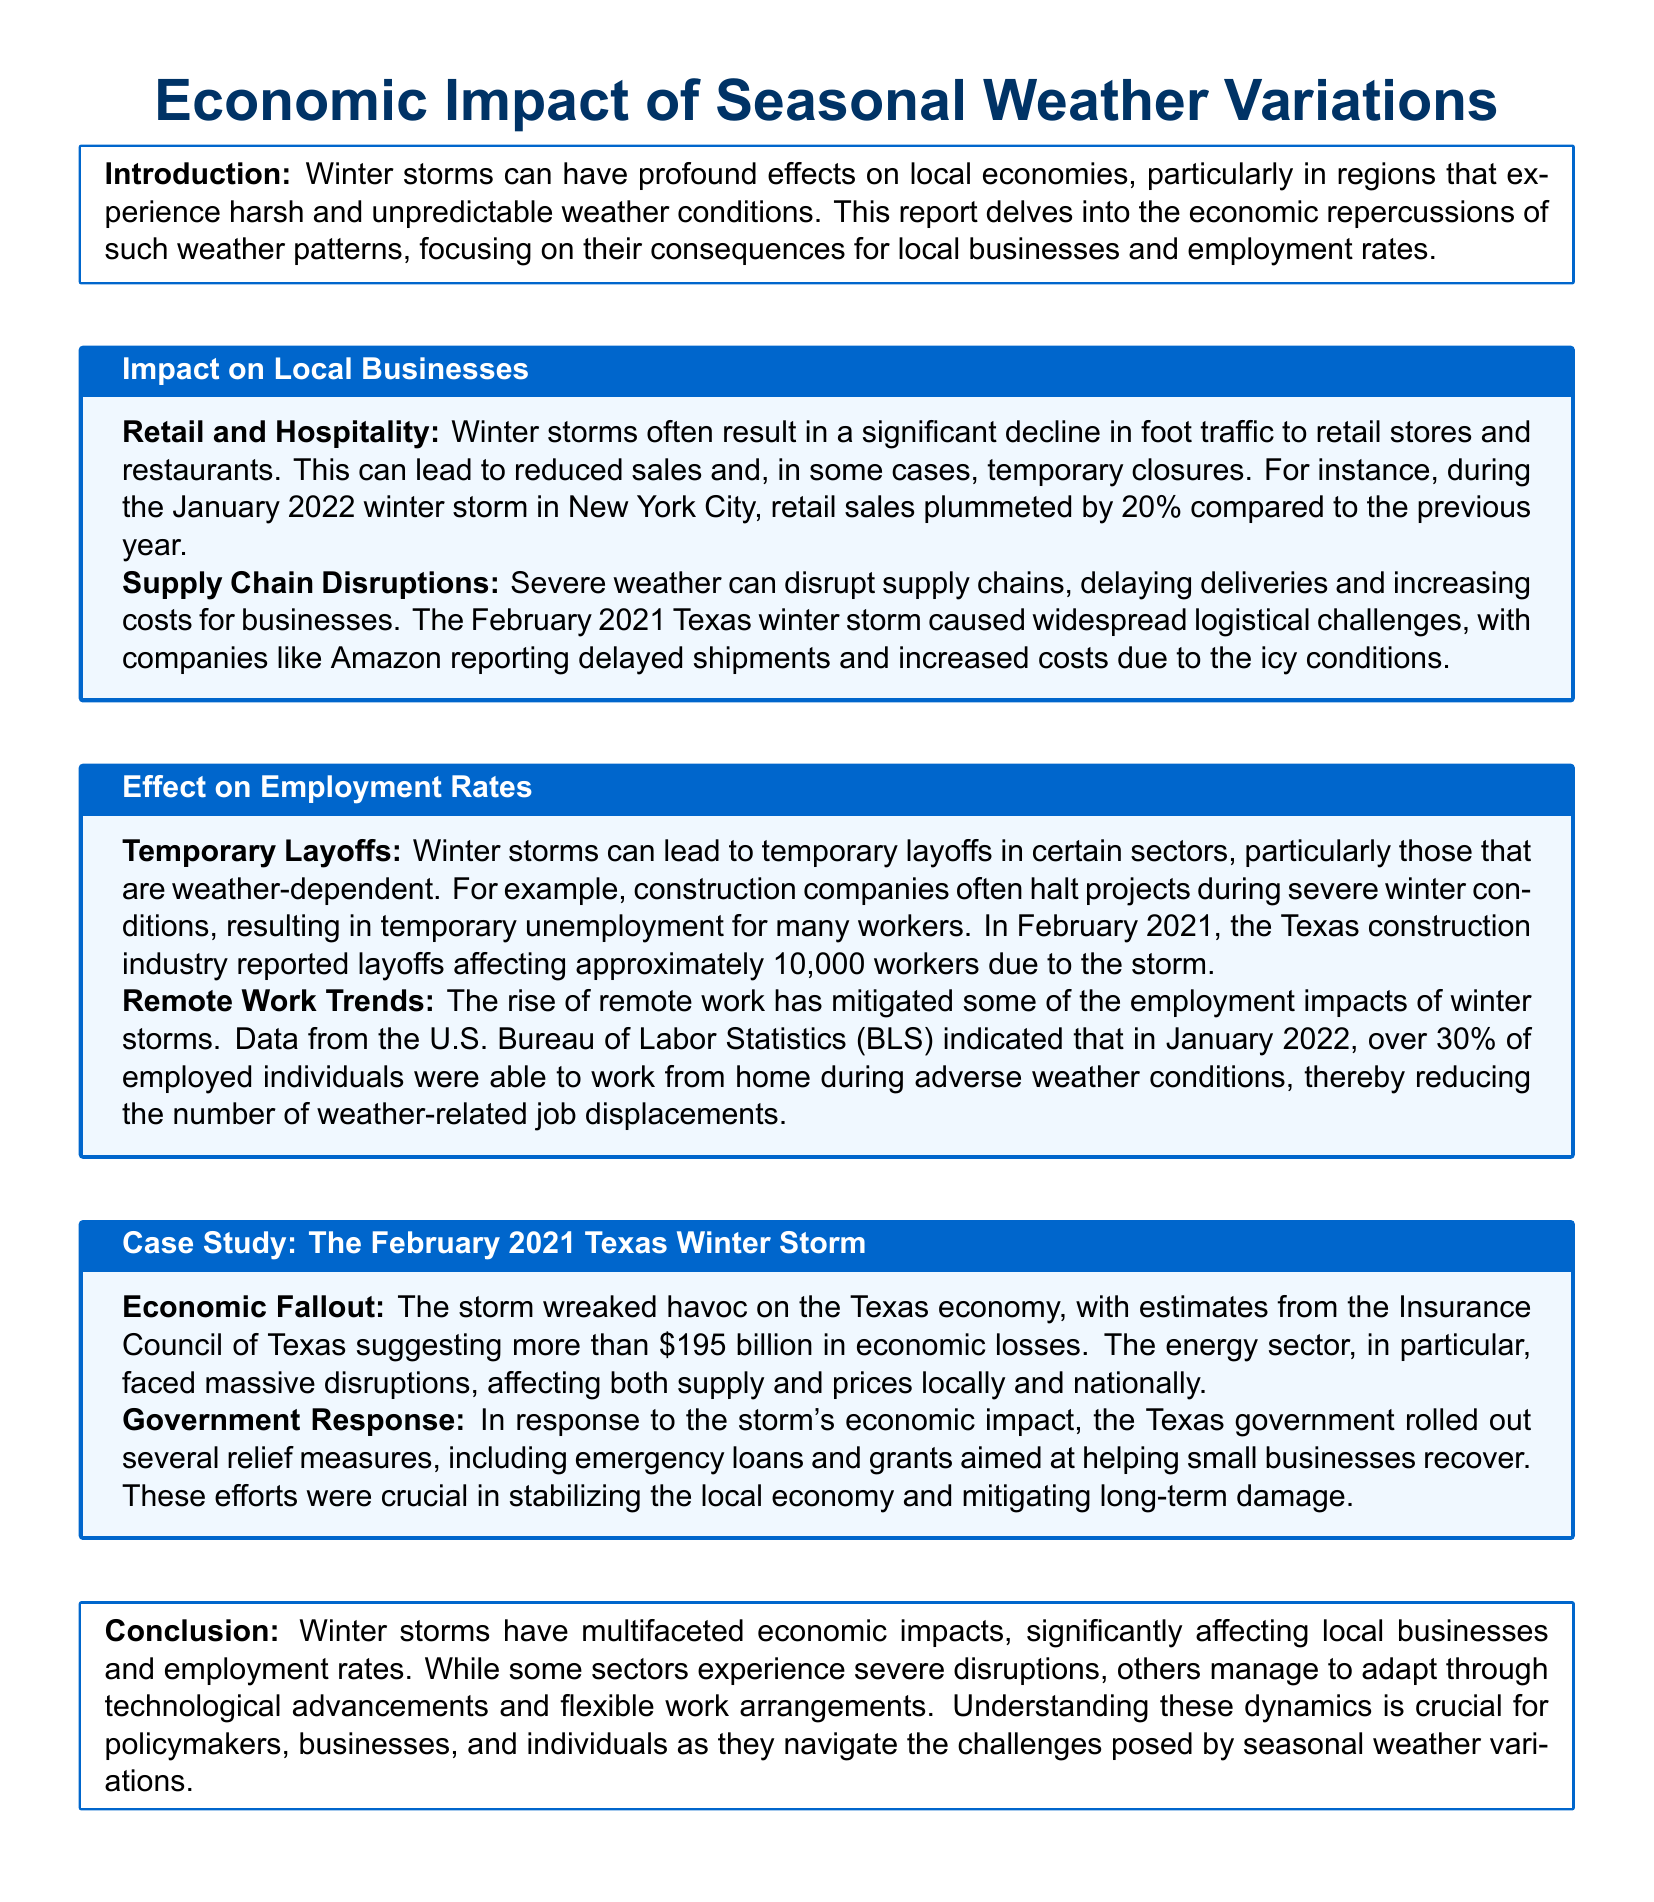What was the percentage decline in retail sales during the January 2022 winter storm? The report states that retail sales plummeted by 20% compared to the previous year during the January 2022 winter storm in New York City.
Answer: 20% How many workers were affected by layoffs in the Texas construction industry due to the February 2021 winter storm? In February 2021, the Texas construction industry reported layoffs affecting approximately 10,000 workers due to the storm.
Answer: 10,000 What was the estimated economic loss from the February 2021 Texas winter storm? The economic fallout from the storm included estimates of more than $195 billion in economic losses according to the Insurance Council of Texas.
Answer: $195 billion What percentage of employed individuals were able to work from home during adverse weather conditions in January 2022? The report provides data from the U.S. Bureau of Labor Statistics indicating that over 30% of employed individuals were able to work from home during such conditions.
Answer: 30% Which sector faced massive disruptions affecting both supply and prices during the February 2021 winter storm? The document highlights that the energy sector faced massive disruptions because of the weather conditions.
Answer: Energy sector What type of relief measures did the Texas government roll out in response to the winter storm's economic impact? The report indicates that the Texas government introduced emergency loans and grants aimed at helping small businesses recover from the economic fallout of the storm.
Answer: Emergency loans and grants What is the primary focus of this report? The report delves into the economic repercussions of winter storms, particularly focusing on their consequences for local businesses and employment rates.
Answer: Economic repercussions What are two areas significantly affected by winter storms according to this report? The document outlines that winter storms affect local businesses, specifically retail and hospitality, as well as employment rates leading to temporary layoffs.
Answer: Local businesses and employment rates 